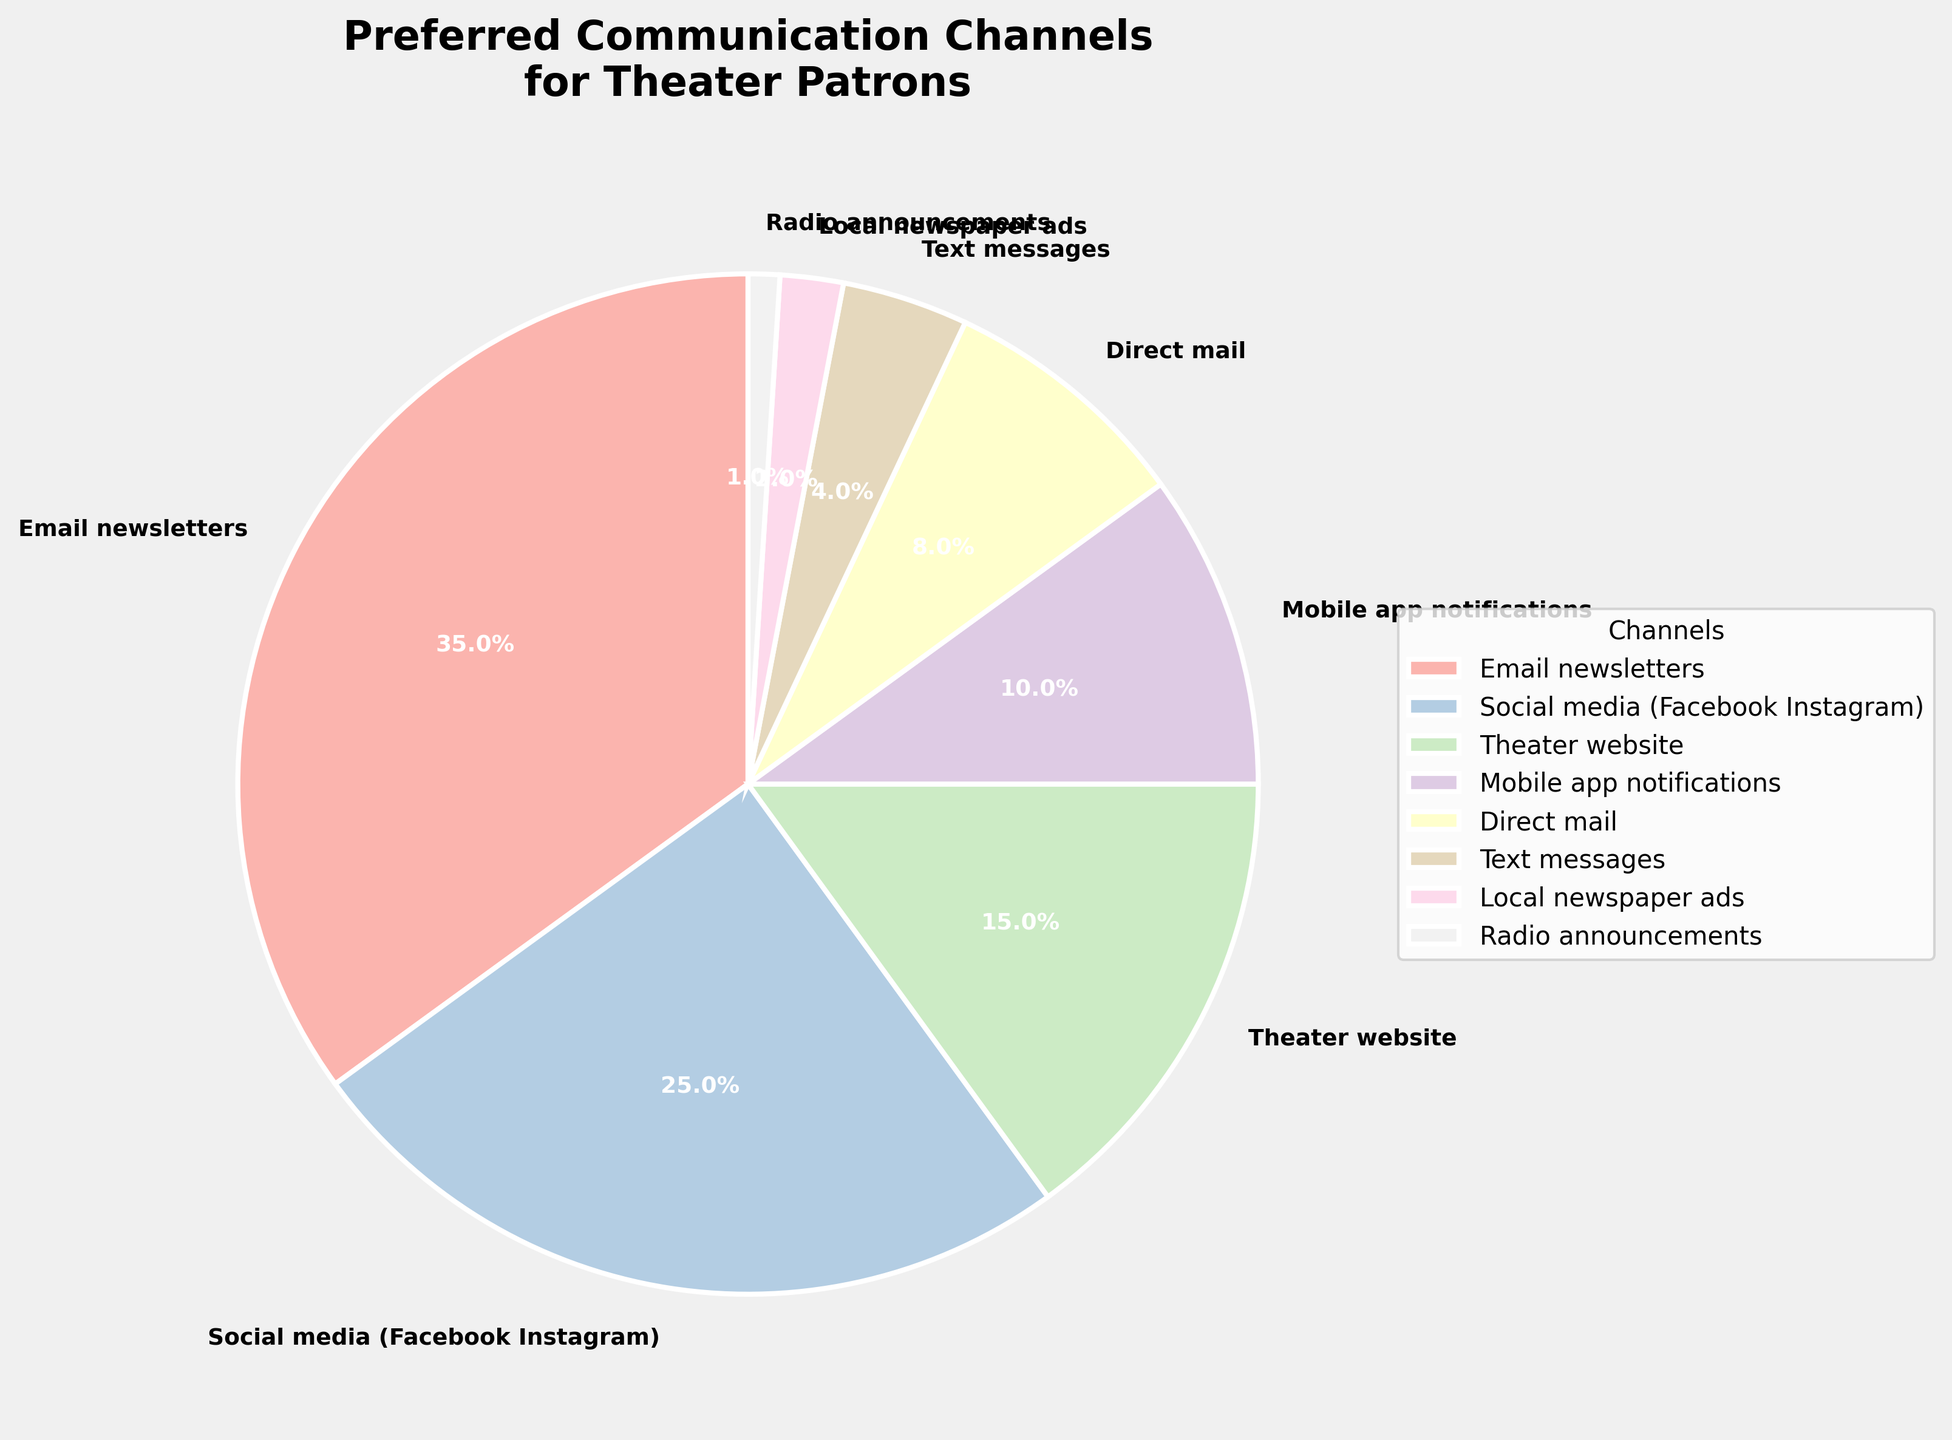What percentage of theater patrons prefer Email newsletters over Direct mail? To find the percentage of theater patrons that prefer Email newsletters over Direct mail, we look at the values associated with each communication channel. Email newsletters have 35% and Direct mail has 8%. So, we calculate the difference: 35% - 8% = 27%.
Answer: 27% Which communication channel is preferred by the least number of theater patrons? To determine which communication channel is preferred by the least number of theater patrons, examine the percentages listed in the pie chart. Radio announcements have the smallest percentage at 1%.
Answer: Radio announcements What is the combined percentage of theater patrons who prefer receiving promotional information via the theater website and the mobile app notifications? To calculate the combined percentage of those who prefer the theater website and mobile app notifications, we add their percentages. The theater website has 15% and mobile app notifications have 10%. Adding these together, 15% + 10% = 25%.
Answer: 25% Is the percentage of theater patrons who prefer Social media greater than those who prefer Mobile app notifications and Text messages combined? To determine this, we compare the percentage for Social media to the combined percentage of Mobile app notifications and Text messages. Social media has 25%, while Mobile app notifications have 10% and Text messages have 4%. Adding the latter two, 10% + 4% = 14%. Since 25% is greater than 14%, Social media has a higher percentage.
Answer: Yes Which two communication channels combined have the same percentage as Social media? To find two communication channels that together match the percentage of Social media (25%), we explore various combinations. The combination of Theater website (15%) and Mobile app notifications (10%) adds up to 25%, matching the percentage of Social media.
Answer: Theater website and Mobile app notifications What is the total percentage of theater patrons who prefer either Direct mail or Local newspaper ads? To determine the total percentage, add the percentages for Direct mail and Local newspaper ads. Direct mail has 8% and Local newspaper ads have 2%. Therefore, 8% + 2% = 10%.
Answer: 10% Among Email newsletters, Social media, and Text messages, which has the highest preference and by how much percentage is it greater than the least preferred among them? Email newsletters, Social media, and Text messages have percentages of 35%, 25%, and 4% respectively. Email newsletters have the highest preference at 35%, and Text messages have the least at 4%. The difference between them is 35% - 4% = 31%.
Answer: Email newsletters; 31% What proportion of the total preference does Local newspaper ads and Radio announcements together represent? To find the proportion, add the percentages for Local newspaper ads and Radio announcements and then divide by the total (100%). Local newspaper ads have 2% and Radio announcements have 1%. So, (2% + 1%) / 100% = 3%.
Answer: 3% 